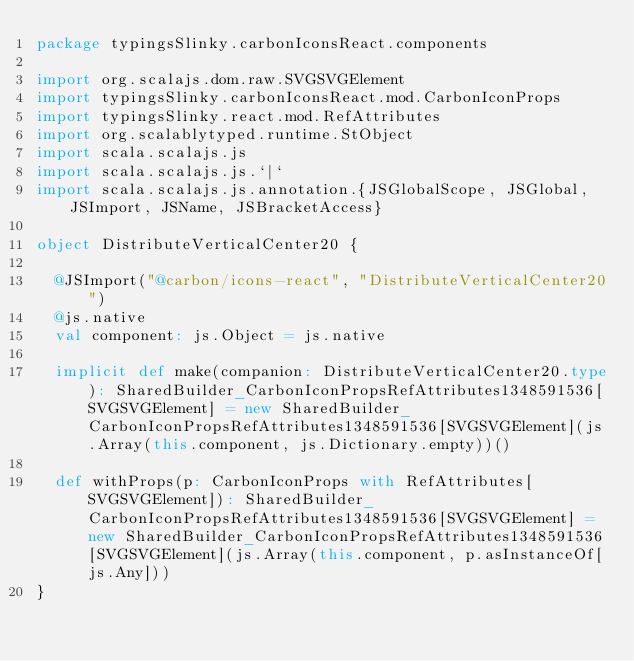Convert code to text. <code><loc_0><loc_0><loc_500><loc_500><_Scala_>package typingsSlinky.carbonIconsReact.components

import org.scalajs.dom.raw.SVGSVGElement
import typingsSlinky.carbonIconsReact.mod.CarbonIconProps
import typingsSlinky.react.mod.RefAttributes
import org.scalablytyped.runtime.StObject
import scala.scalajs.js
import scala.scalajs.js.`|`
import scala.scalajs.js.annotation.{JSGlobalScope, JSGlobal, JSImport, JSName, JSBracketAccess}

object DistributeVerticalCenter20 {
  
  @JSImport("@carbon/icons-react", "DistributeVerticalCenter20")
  @js.native
  val component: js.Object = js.native
  
  implicit def make(companion: DistributeVerticalCenter20.type): SharedBuilder_CarbonIconPropsRefAttributes1348591536[SVGSVGElement] = new SharedBuilder_CarbonIconPropsRefAttributes1348591536[SVGSVGElement](js.Array(this.component, js.Dictionary.empty))()
  
  def withProps(p: CarbonIconProps with RefAttributes[SVGSVGElement]): SharedBuilder_CarbonIconPropsRefAttributes1348591536[SVGSVGElement] = new SharedBuilder_CarbonIconPropsRefAttributes1348591536[SVGSVGElement](js.Array(this.component, p.asInstanceOf[js.Any]))
}
</code> 